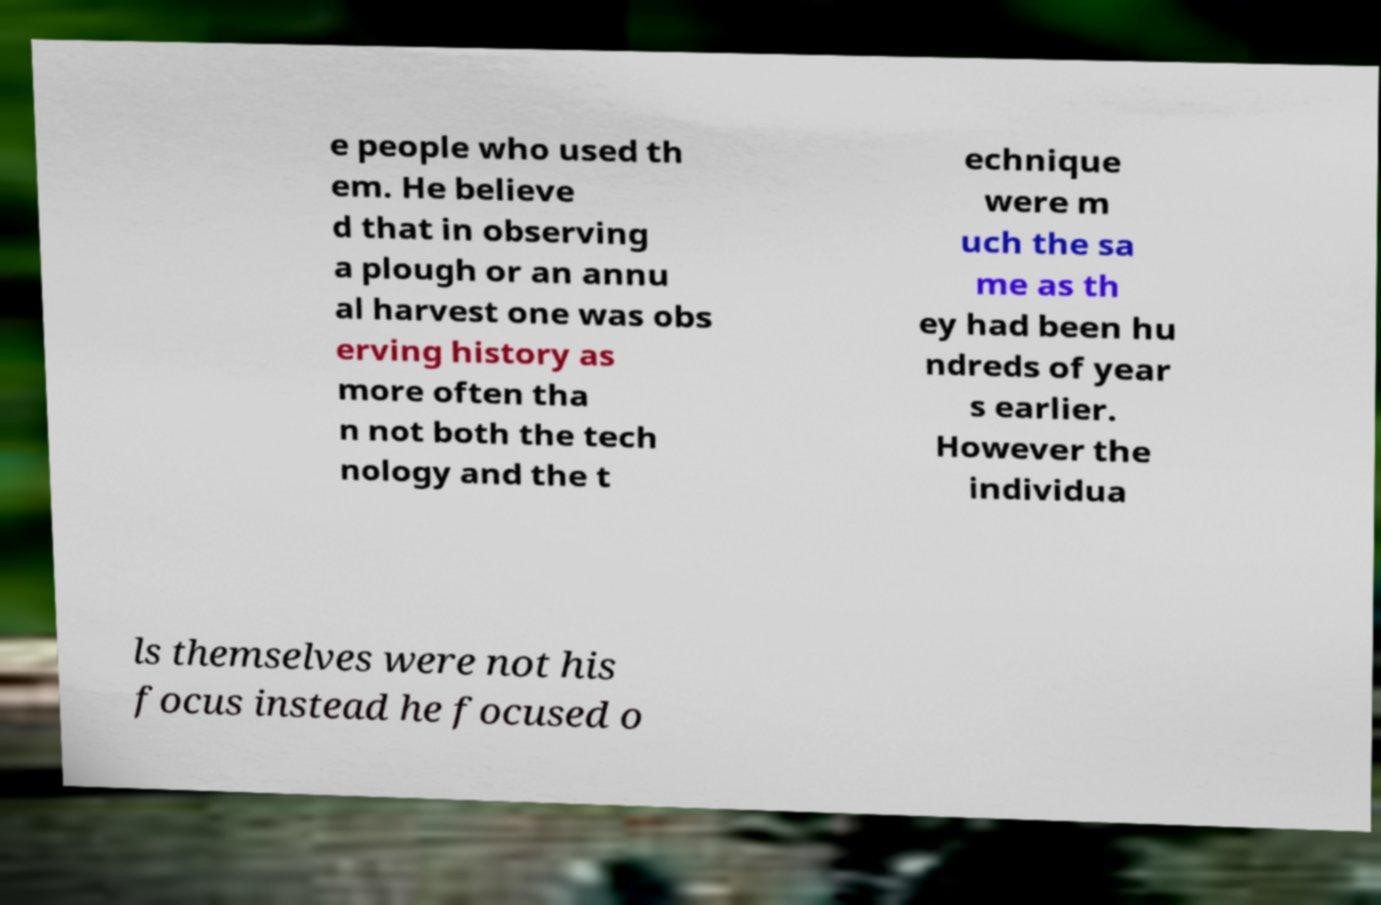Please identify and transcribe the text found in this image. e people who used th em. He believe d that in observing a plough or an annu al harvest one was obs erving history as more often tha n not both the tech nology and the t echnique were m uch the sa me as th ey had been hu ndreds of year s earlier. However the individua ls themselves were not his focus instead he focused o 